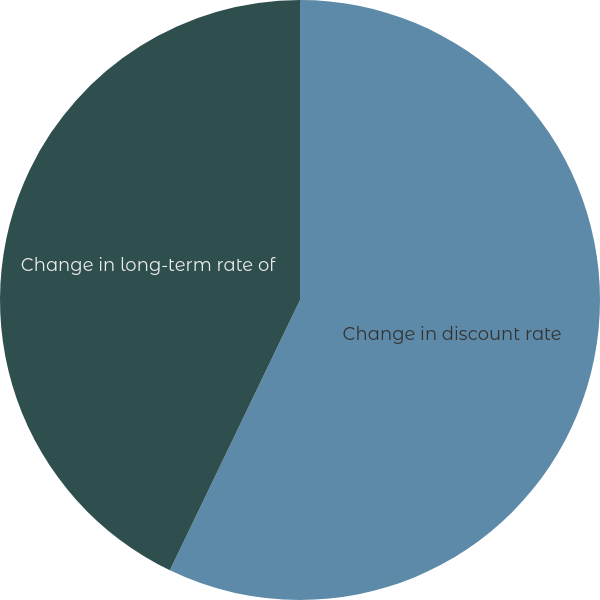Convert chart. <chart><loc_0><loc_0><loc_500><loc_500><pie_chart><fcel>Change in discount rate<fcel>Change in long-term rate of<nl><fcel>57.14%<fcel>42.86%<nl></chart> 